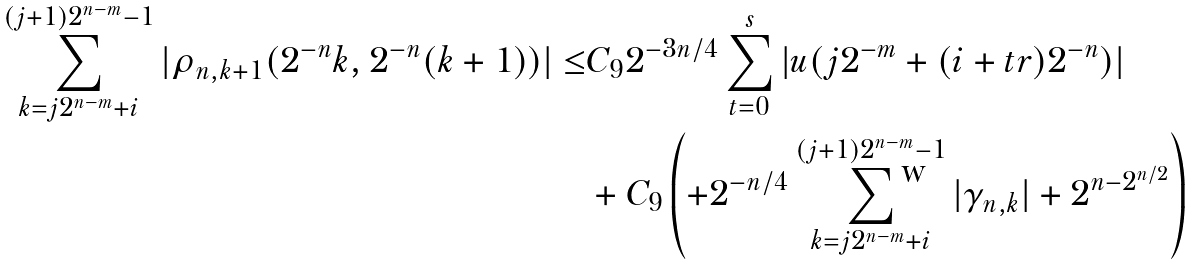<formula> <loc_0><loc_0><loc_500><loc_500>\sum _ { k = j 2 ^ { n - m } + i } ^ { ( j + 1 ) 2 ^ { n - m } - 1 } | \rho _ { n , k + 1 } ( 2 ^ { - n } k , 2 ^ { - n } ( k + 1 ) ) | \leq & C _ { 9 } 2 ^ { - 3 n / 4 } \sum _ { t = 0 } ^ { s } | u ( j 2 ^ { - m } + ( i + t r ) 2 ^ { - n } ) | \\ & + C _ { 9 } \left ( + 2 ^ { - n / 4 } \sum _ { k = j 2 ^ { n - m } + i } ^ { ( j + 1 ) 2 ^ { n - m } - 1 } | \gamma _ { n , k } | + 2 ^ { n - 2 ^ { n / 2 } } \right )</formula> 